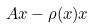Convert formula to latex. <formula><loc_0><loc_0><loc_500><loc_500>A x - \rho ( x ) x</formula> 